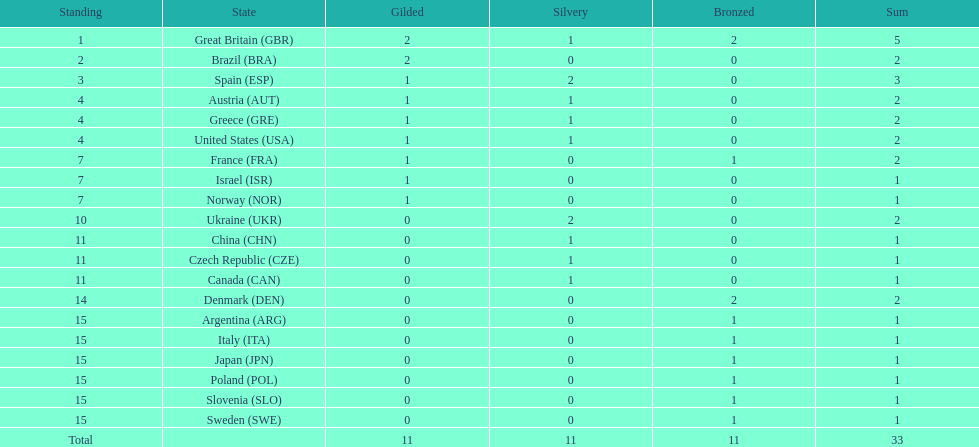What is the count of countries that have achieved at least one gold and one silver medal? 5. 